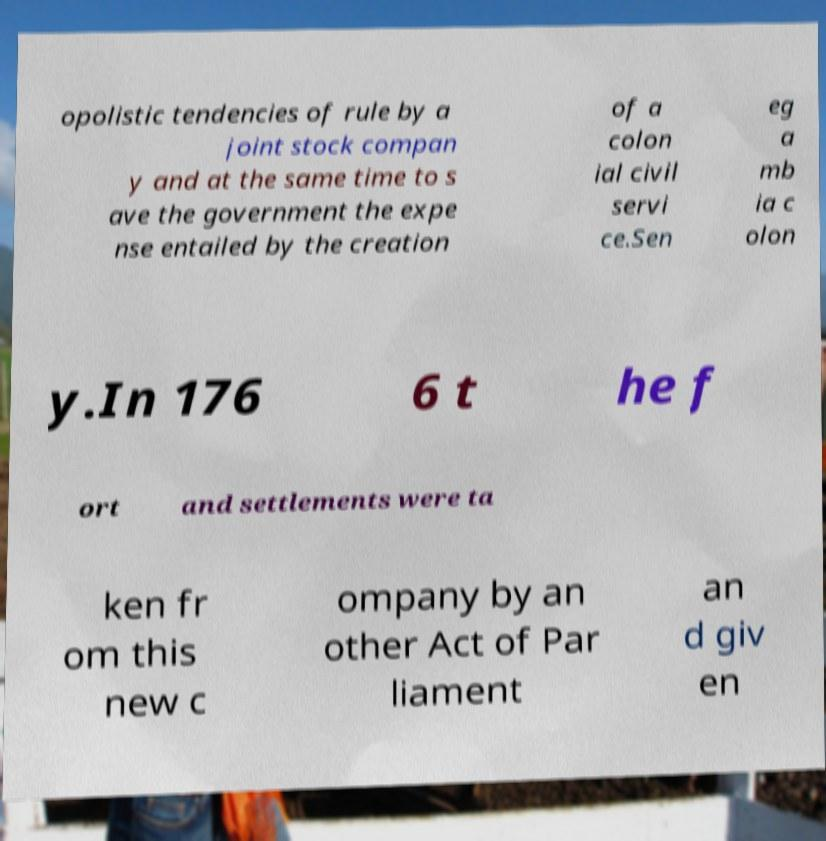What messages or text are displayed in this image? I need them in a readable, typed format. opolistic tendencies of rule by a joint stock compan y and at the same time to s ave the government the expe nse entailed by the creation of a colon ial civil servi ce.Sen eg a mb ia c olon y.In 176 6 t he f ort and settlements were ta ken fr om this new c ompany by an other Act of Par liament an d giv en 